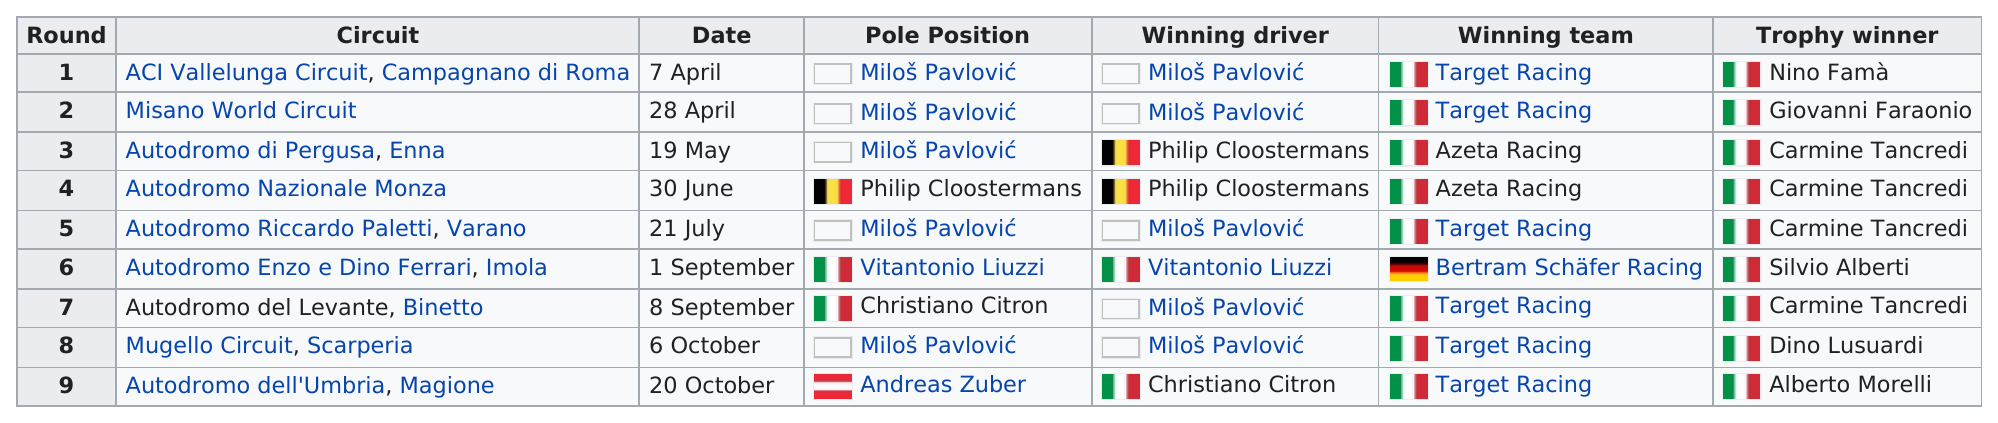Identify some key points in this picture. Target Racing had more winning teams than Azeta Racing during their heyday. Bertram Schäfer Racing, the winning team that won the least, is the team that won the least number of races out of all the winning teams. In the sixth round, there was no Italian team that won the game. Miloš Pavlović is a racer who has won at least two rounds. The Misano World Circuit was won by Target Racing, not Azeta Racing, as per the official results. 